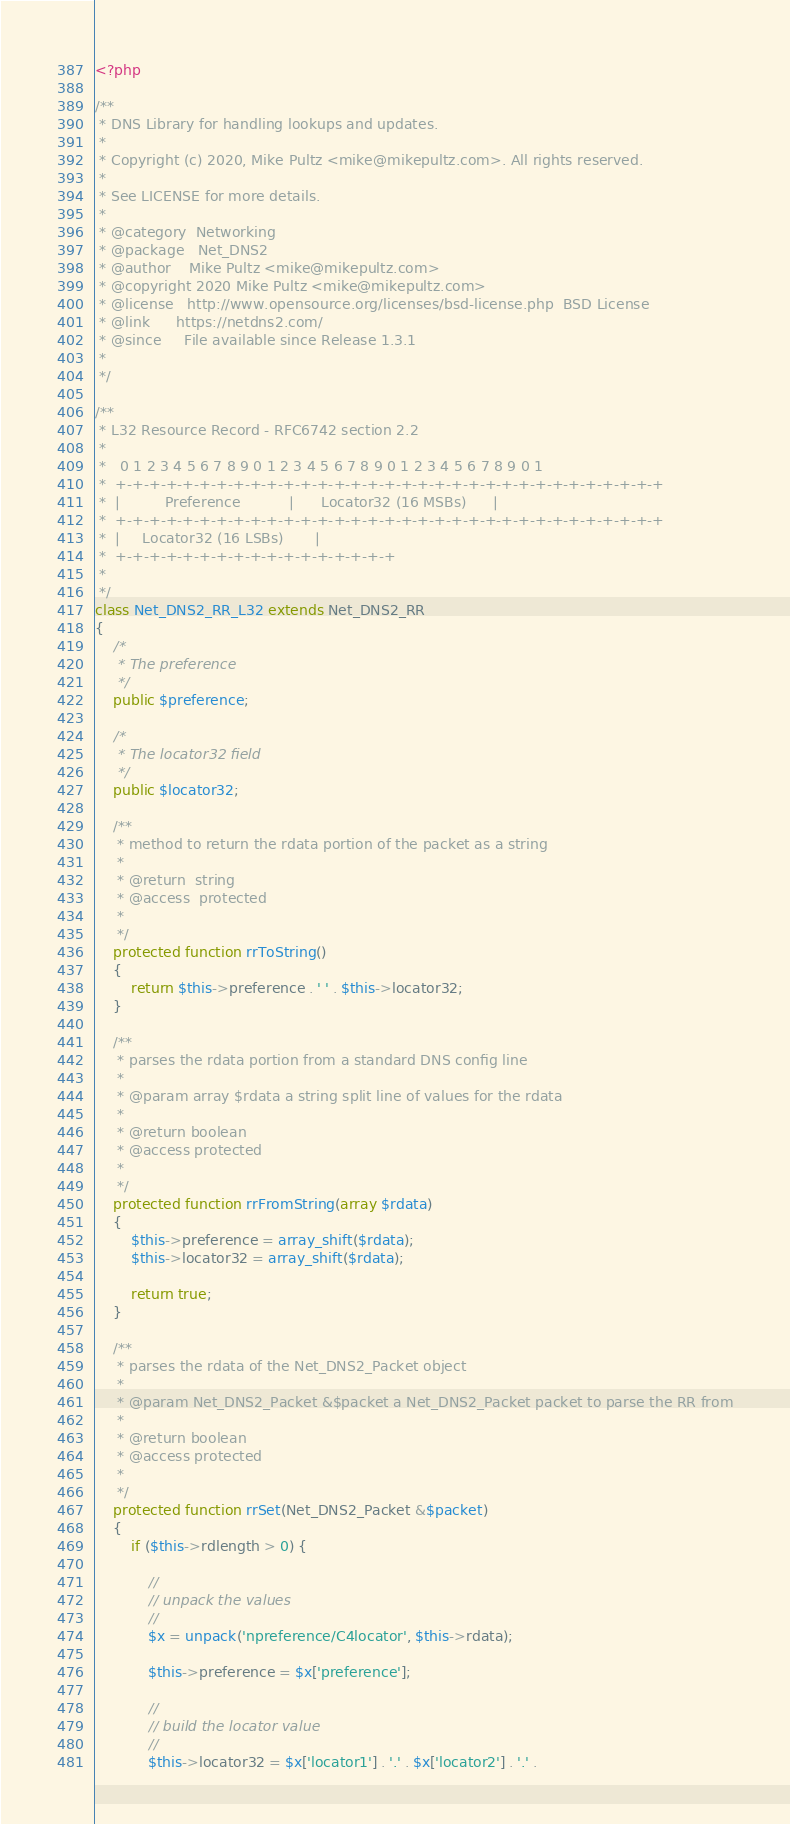Convert code to text. <code><loc_0><loc_0><loc_500><loc_500><_PHP_><?php

/**
 * DNS Library for handling lookups and updates. 
 *
 * Copyright (c) 2020, Mike Pultz <mike@mikepultz.com>. All rights reserved.
 *
 * See LICENSE for more details.
 *
 * @category  Networking
 * @package   Net_DNS2
 * @author    Mike Pultz <mike@mikepultz.com>
 * @copyright 2020 Mike Pultz <mike@mikepultz.com>
 * @license   http://www.opensource.org/licenses/bsd-license.php  BSD License
 * @link      https://netdns2.com/
 * @since     File available since Release 1.3.1
 *
 */

/**
 * L32 Resource Record - RFC6742 section 2.2
 *
 *   0 1 2 3 4 5 6 7 8 9 0 1 2 3 4 5 6 7 8 9 0 1 2 3 4 5 6 7 8 9 0 1
 *  +-+-+-+-+-+-+-+-+-+-+-+-+-+-+-+-+-+-+-+-+-+-+-+-+-+-+-+-+-+-+-+-+
 *  |          Preference           |      Locator32 (16 MSBs)      |
 *  +-+-+-+-+-+-+-+-+-+-+-+-+-+-+-+-+-+-+-+-+-+-+-+-+-+-+-+-+-+-+-+-+
 *  |     Locator32 (16 LSBs)       |
 *  +-+-+-+-+-+-+-+-+-+-+-+-+-+-+-+-+
 *
 */
class Net_DNS2_RR_L32 extends Net_DNS2_RR
{
    /*
     * The preference
     */
    public $preference;

    /*
     * The locator32 field
     */
    public $locator32;

    /**
     * method to return the rdata portion of the packet as a string
     *
     * @return  string
     * @access  protected
     *
     */
    protected function rrToString()
    {
        return $this->preference . ' ' . $this->locator32;
    }

    /**
     * parses the rdata portion from a standard DNS config line
     *
     * @param array $rdata a string split line of values for the rdata
     *
     * @return boolean
     * @access protected
     *
     */
    protected function rrFromString(array $rdata)
    {
        $this->preference = array_shift($rdata);
        $this->locator32 = array_shift($rdata);

        return true;
    }

    /**
     * parses the rdata of the Net_DNS2_Packet object
     *
     * @param Net_DNS2_Packet &$packet a Net_DNS2_Packet packet to parse the RR from
     *
     * @return boolean
     * @access protected
     * 
     */
    protected function rrSet(Net_DNS2_Packet &$packet)
    {
        if ($this->rdlength > 0) {

            //
            // unpack the values
            //
            $x = unpack('npreference/C4locator', $this->rdata);

            $this->preference = $x['preference'];

            //
            // build the locator value
            //
            $this->locator32 = $x['locator1'] . '.' . $x['locator2'] . '.' .</code> 